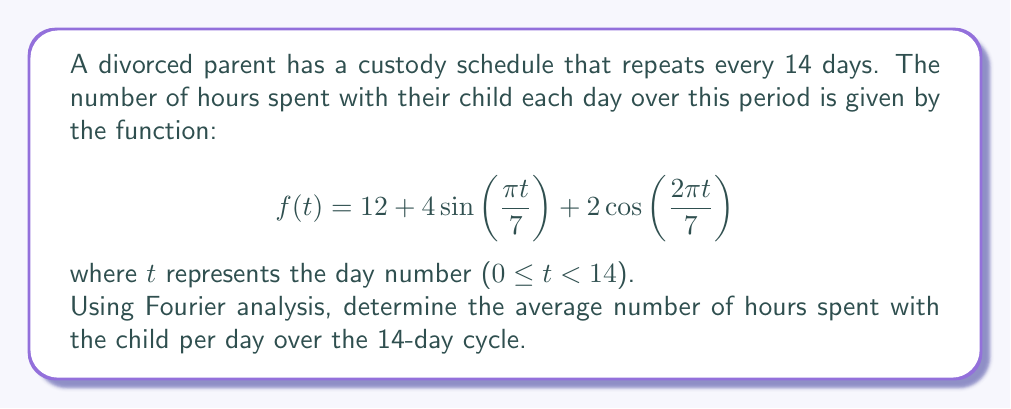Teach me how to tackle this problem. To solve this problem, we need to understand that the average value of a periodic function over its period is equal to the constant term (a₀) in its Fourier series expansion. In this case, our function is already expressed in a form similar to a Fourier series.

The general form of a Fourier series is:

$$f(t) = \frac{a_0}{2} + \sum_{n=1}^{\infty} [a_n \cos(\frac{2\pi n t}{T}) + b_n \sin(\frac{2\pi n t}{T})]$$

Where T is the period of the function.

Comparing our given function to this general form:

1) The period T = 14 days
2) $\frac{a_0}{2} = 12$ (the constant term)
3) The sine and cosine terms represent the varying components and don't affect the average

Therefore, the average value of the function over its period is simply the constant term, which is:

$$\text{Average} = a_0 = 2 * 12 = 24$$

This means that over the 14-day cycle, the parent spends an average of 24 hours per day with their child.
Answer: The average number of hours spent with the child per day over the 14-day cycle is 24 hours. 